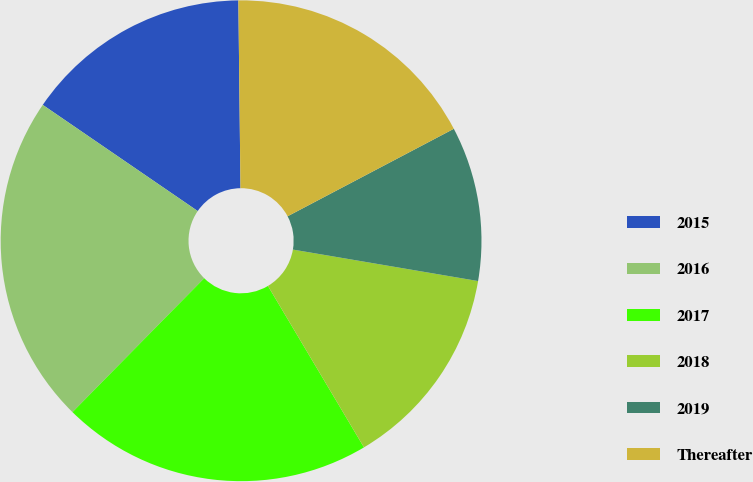Convert chart to OTSL. <chart><loc_0><loc_0><loc_500><loc_500><pie_chart><fcel>2015<fcel>2016<fcel>2017<fcel>2018<fcel>2019<fcel>Thereafter<nl><fcel>15.26%<fcel>22.19%<fcel>20.91%<fcel>13.78%<fcel>10.39%<fcel>17.47%<nl></chart> 